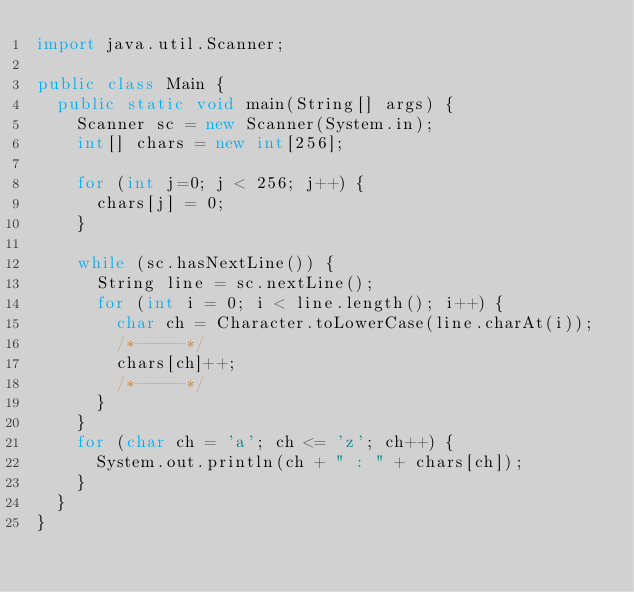<code> <loc_0><loc_0><loc_500><loc_500><_Java_>import java.util.Scanner;

public class Main {
	public static void main(String[] args) {
		Scanner sc = new Scanner(System.in);
		int[] chars = new int[256];

		for (int j=0; j < 256; j++) {
			chars[j] = 0;
		}

		while (sc.hasNextLine()) {
			String line = sc.nextLine();
			for (int i = 0; i < line.length(); i++) {
				char ch = Character.toLowerCase(line.charAt(i));
				/*-----*/
				chars[ch]++;
				/*-----*/
			}
		}
		for (char ch = 'a'; ch <= 'z'; ch++) {
			System.out.println(ch + " : " + chars[ch]);
		}
	}
}</code> 